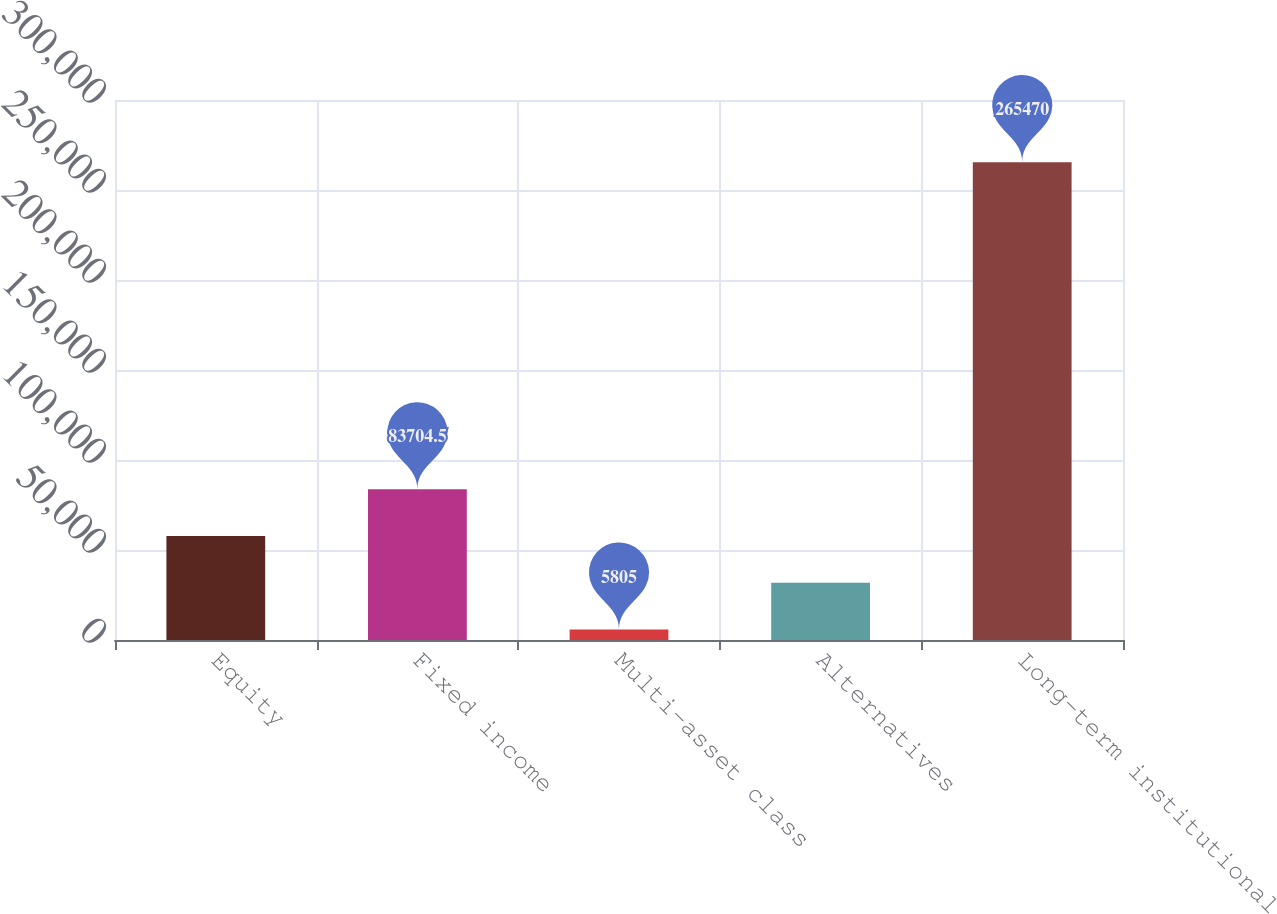Convert chart to OTSL. <chart><loc_0><loc_0><loc_500><loc_500><bar_chart><fcel>Equity<fcel>Fixed income<fcel>Multi-asset class<fcel>Alternatives<fcel>Long-term institutional<nl><fcel>57738<fcel>83704.5<fcel>5805<fcel>31771.5<fcel>265470<nl></chart> 